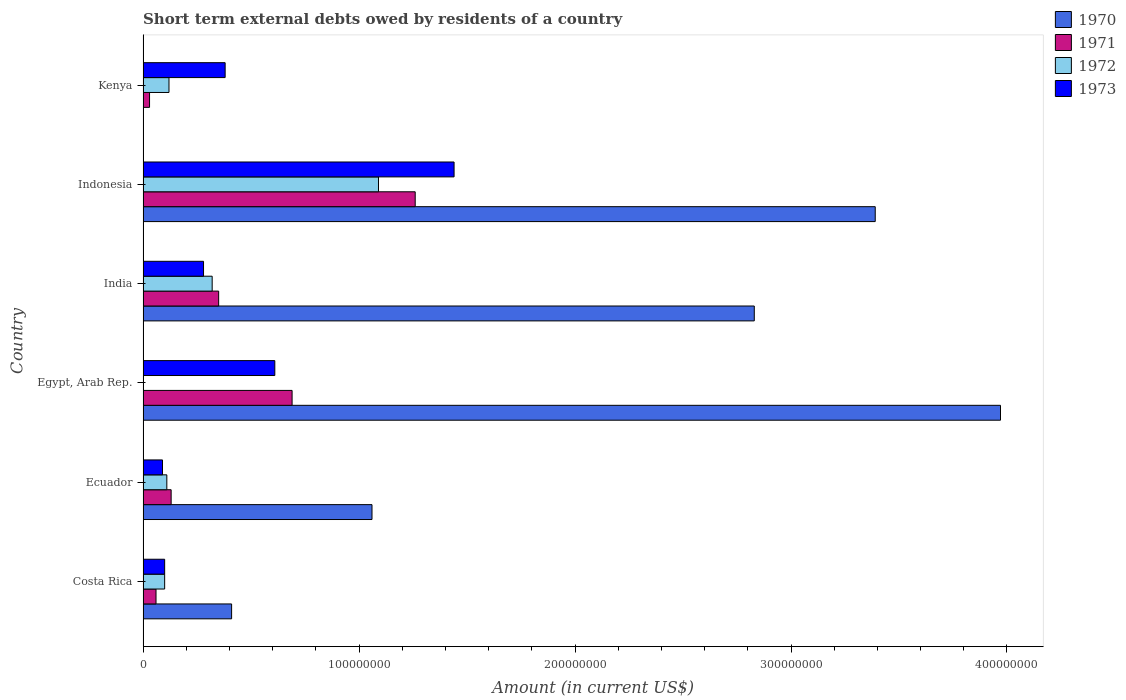How many bars are there on the 2nd tick from the top?
Offer a very short reply. 4. What is the label of the 6th group of bars from the top?
Offer a very short reply. Costa Rica. What is the amount of short-term external debts owed by residents in 1971 in Ecuador?
Give a very brief answer. 1.30e+07. Across all countries, what is the maximum amount of short-term external debts owed by residents in 1972?
Provide a succinct answer. 1.09e+08. Across all countries, what is the minimum amount of short-term external debts owed by residents in 1971?
Provide a short and direct response. 3.00e+06. In which country was the amount of short-term external debts owed by residents in 1972 maximum?
Ensure brevity in your answer.  Indonesia. What is the total amount of short-term external debts owed by residents in 1973 in the graph?
Offer a terse response. 2.90e+08. What is the difference between the amount of short-term external debts owed by residents in 1972 in Costa Rica and that in Ecuador?
Make the answer very short. -1.00e+06. What is the difference between the amount of short-term external debts owed by residents in 1973 in Egypt, Arab Rep. and the amount of short-term external debts owed by residents in 1972 in Costa Rica?
Give a very brief answer. 5.10e+07. What is the average amount of short-term external debts owed by residents in 1973 per country?
Make the answer very short. 4.83e+07. What is the difference between the amount of short-term external debts owed by residents in 1970 and amount of short-term external debts owed by residents in 1972 in Indonesia?
Your answer should be compact. 2.30e+08. What is the ratio of the amount of short-term external debts owed by residents in 1973 in Costa Rica to that in Egypt, Arab Rep.?
Your response must be concise. 0.16. Is the amount of short-term external debts owed by residents in 1973 in Ecuador less than that in Kenya?
Your answer should be very brief. Yes. Is the difference between the amount of short-term external debts owed by residents in 1970 in India and Indonesia greater than the difference between the amount of short-term external debts owed by residents in 1972 in India and Indonesia?
Your answer should be compact. Yes. What is the difference between the highest and the second highest amount of short-term external debts owed by residents in 1970?
Keep it short and to the point. 5.80e+07. What is the difference between the highest and the lowest amount of short-term external debts owed by residents in 1973?
Offer a terse response. 1.35e+08. Is the sum of the amount of short-term external debts owed by residents in 1973 in Costa Rica and India greater than the maximum amount of short-term external debts owed by residents in 1972 across all countries?
Provide a succinct answer. No. Is it the case that in every country, the sum of the amount of short-term external debts owed by residents in 1970 and amount of short-term external debts owed by residents in 1972 is greater than the amount of short-term external debts owed by residents in 1971?
Offer a terse response. Yes. How many countries are there in the graph?
Your answer should be very brief. 6. Does the graph contain any zero values?
Provide a succinct answer. Yes. Does the graph contain grids?
Your answer should be compact. No. What is the title of the graph?
Your answer should be very brief. Short term external debts owed by residents of a country. Does "1995" appear as one of the legend labels in the graph?
Offer a terse response. No. What is the label or title of the X-axis?
Provide a succinct answer. Amount (in current US$). What is the label or title of the Y-axis?
Ensure brevity in your answer.  Country. What is the Amount (in current US$) of 1970 in Costa Rica?
Ensure brevity in your answer.  4.10e+07. What is the Amount (in current US$) in 1972 in Costa Rica?
Ensure brevity in your answer.  1.00e+07. What is the Amount (in current US$) of 1973 in Costa Rica?
Give a very brief answer. 1.00e+07. What is the Amount (in current US$) in 1970 in Ecuador?
Your response must be concise. 1.06e+08. What is the Amount (in current US$) of 1971 in Ecuador?
Give a very brief answer. 1.30e+07. What is the Amount (in current US$) in 1972 in Ecuador?
Keep it short and to the point. 1.10e+07. What is the Amount (in current US$) of 1973 in Ecuador?
Your answer should be very brief. 9.00e+06. What is the Amount (in current US$) in 1970 in Egypt, Arab Rep.?
Offer a very short reply. 3.97e+08. What is the Amount (in current US$) in 1971 in Egypt, Arab Rep.?
Keep it short and to the point. 6.90e+07. What is the Amount (in current US$) in 1972 in Egypt, Arab Rep.?
Provide a short and direct response. 0. What is the Amount (in current US$) in 1973 in Egypt, Arab Rep.?
Keep it short and to the point. 6.10e+07. What is the Amount (in current US$) of 1970 in India?
Ensure brevity in your answer.  2.83e+08. What is the Amount (in current US$) of 1971 in India?
Offer a terse response. 3.50e+07. What is the Amount (in current US$) in 1972 in India?
Make the answer very short. 3.20e+07. What is the Amount (in current US$) of 1973 in India?
Provide a succinct answer. 2.80e+07. What is the Amount (in current US$) in 1970 in Indonesia?
Your answer should be compact. 3.39e+08. What is the Amount (in current US$) of 1971 in Indonesia?
Offer a very short reply. 1.26e+08. What is the Amount (in current US$) of 1972 in Indonesia?
Offer a very short reply. 1.09e+08. What is the Amount (in current US$) in 1973 in Indonesia?
Give a very brief answer. 1.44e+08. What is the Amount (in current US$) in 1970 in Kenya?
Your response must be concise. 0. What is the Amount (in current US$) in 1971 in Kenya?
Ensure brevity in your answer.  3.00e+06. What is the Amount (in current US$) of 1973 in Kenya?
Your answer should be very brief. 3.80e+07. Across all countries, what is the maximum Amount (in current US$) of 1970?
Provide a succinct answer. 3.97e+08. Across all countries, what is the maximum Amount (in current US$) in 1971?
Provide a succinct answer. 1.26e+08. Across all countries, what is the maximum Amount (in current US$) of 1972?
Your response must be concise. 1.09e+08. Across all countries, what is the maximum Amount (in current US$) of 1973?
Your response must be concise. 1.44e+08. Across all countries, what is the minimum Amount (in current US$) of 1971?
Ensure brevity in your answer.  3.00e+06. Across all countries, what is the minimum Amount (in current US$) of 1973?
Offer a terse response. 9.00e+06. What is the total Amount (in current US$) of 1970 in the graph?
Offer a very short reply. 1.17e+09. What is the total Amount (in current US$) in 1971 in the graph?
Ensure brevity in your answer.  2.52e+08. What is the total Amount (in current US$) of 1972 in the graph?
Offer a terse response. 1.74e+08. What is the total Amount (in current US$) in 1973 in the graph?
Your answer should be very brief. 2.90e+08. What is the difference between the Amount (in current US$) of 1970 in Costa Rica and that in Ecuador?
Your answer should be very brief. -6.50e+07. What is the difference between the Amount (in current US$) of 1971 in Costa Rica and that in Ecuador?
Offer a terse response. -7.00e+06. What is the difference between the Amount (in current US$) of 1972 in Costa Rica and that in Ecuador?
Provide a succinct answer. -1.00e+06. What is the difference between the Amount (in current US$) of 1973 in Costa Rica and that in Ecuador?
Offer a terse response. 1.00e+06. What is the difference between the Amount (in current US$) of 1970 in Costa Rica and that in Egypt, Arab Rep.?
Offer a terse response. -3.56e+08. What is the difference between the Amount (in current US$) in 1971 in Costa Rica and that in Egypt, Arab Rep.?
Give a very brief answer. -6.30e+07. What is the difference between the Amount (in current US$) in 1973 in Costa Rica and that in Egypt, Arab Rep.?
Ensure brevity in your answer.  -5.10e+07. What is the difference between the Amount (in current US$) of 1970 in Costa Rica and that in India?
Offer a terse response. -2.42e+08. What is the difference between the Amount (in current US$) of 1971 in Costa Rica and that in India?
Give a very brief answer. -2.90e+07. What is the difference between the Amount (in current US$) of 1972 in Costa Rica and that in India?
Ensure brevity in your answer.  -2.20e+07. What is the difference between the Amount (in current US$) of 1973 in Costa Rica and that in India?
Give a very brief answer. -1.80e+07. What is the difference between the Amount (in current US$) in 1970 in Costa Rica and that in Indonesia?
Provide a short and direct response. -2.98e+08. What is the difference between the Amount (in current US$) in 1971 in Costa Rica and that in Indonesia?
Keep it short and to the point. -1.20e+08. What is the difference between the Amount (in current US$) in 1972 in Costa Rica and that in Indonesia?
Make the answer very short. -9.90e+07. What is the difference between the Amount (in current US$) of 1973 in Costa Rica and that in Indonesia?
Make the answer very short. -1.34e+08. What is the difference between the Amount (in current US$) in 1972 in Costa Rica and that in Kenya?
Ensure brevity in your answer.  -2.00e+06. What is the difference between the Amount (in current US$) of 1973 in Costa Rica and that in Kenya?
Your answer should be very brief. -2.80e+07. What is the difference between the Amount (in current US$) of 1970 in Ecuador and that in Egypt, Arab Rep.?
Give a very brief answer. -2.91e+08. What is the difference between the Amount (in current US$) in 1971 in Ecuador and that in Egypt, Arab Rep.?
Ensure brevity in your answer.  -5.60e+07. What is the difference between the Amount (in current US$) in 1973 in Ecuador and that in Egypt, Arab Rep.?
Offer a very short reply. -5.20e+07. What is the difference between the Amount (in current US$) of 1970 in Ecuador and that in India?
Your response must be concise. -1.77e+08. What is the difference between the Amount (in current US$) in 1971 in Ecuador and that in India?
Provide a short and direct response. -2.20e+07. What is the difference between the Amount (in current US$) in 1972 in Ecuador and that in India?
Give a very brief answer. -2.10e+07. What is the difference between the Amount (in current US$) of 1973 in Ecuador and that in India?
Provide a short and direct response. -1.90e+07. What is the difference between the Amount (in current US$) in 1970 in Ecuador and that in Indonesia?
Provide a succinct answer. -2.33e+08. What is the difference between the Amount (in current US$) in 1971 in Ecuador and that in Indonesia?
Give a very brief answer. -1.13e+08. What is the difference between the Amount (in current US$) of 1972 in Ecuador and that in Indonesia?
Ensure brevity in your answer.  -9.80e+07. What is the difference between the Amount (in current US$) of 1973 in Ecuador and that in Indonesia?
Give a very brief answer. -1.35e+08. What is the difference between the Amount (in current US$) of 1971 in Ecuador and that in Kenya?
Offer a terse response. 1.00e+07. What is the difference between the Amount (in current US$) in 1973 in Ecuador and that in Kenya?
Ensure brevity in your answer.  -2.90e+07. What is the difference between the Amount (in current US$) in 1970 in Egypt, Arab Rep. and that in India?
Keep it short and to the point. 1.14e+08. What is the difference between the Amount (in current US$) in 1971 in Egypt, Arab Rep. and that in India?
Offer a very short reply. 3.40e+07. What is the difference between the Amount (in current US$) of 1973 in Egypt, Arab Rep. and that in India?
Provide a succinct answer. 3.30e+07. What is the difference between the Amount (in current US$) in 1970 in Egypt, Arab Rep. and that in Indonesia?
Your response must be concise. 5.80e+07. What is the difference between the Amount (in current US$) of 1971 in Egypt, Arab Rep. and that in Indonesia?
Your answer should be very brief. -5.70e+07. What is the difference between the Amount (in current US$) of 1973 in Egypt, Arab Rep. and that in Indonesia?
Give a very brief answer. -8.30e+07. What is the difference between the Amount (in current US$) of 1971 in Egypt, Arab Rep. and that in Kenya?
Provide a succinct answer. 6.60e+07. What is the difference between the Amount (in current US$) in 1973 in Egypt, Arab Rep. and that in Kenya?
Provide a succinct answer. 2.30e+07. What is the difference between the Amount (in current US$) in 1970 in India and that in Indonesia?
Keep it short and to the point. -5.60e+07. What is the difference between the Amount (in current US$) in 1971 in India and that in Indonesia?
Give a very brief answer. -9.10e+07. What is the difference between the Amount (in current US$) in 1972 in India and that in Indonesia?
Your answer should be compact. -7.70e+07. What is the difference between the Amount (in current US$) of 1973 in India and that in Indonesia?
Your answer should be compact. -1.16e+08. What is the difference between the Amount (in current US$) of 1971 in India and that in Kenya?
Your answer should be compact. 3.20e+07. What is the difference between the Amount (in current US$) in 1972 in India and that in Kenya?
Provide a short and direct response. 2.00e+07. What is the difference between the Amount (in current US$) of 1973 in India and that in Kenya?
Offer a terse response. -1.00e+07. What is the difference between the Amount (in current US$) of 1971 in Indonesia and that in Kenya?
Your answer should be very brief. 1.23e+08. What is the difference between the Amount (in current US$) of 1972 in Indonesia and that in Kenya?
Provide a succinct answer. 9.70e+07. What is the difference between the Amount (in current US$) in 1973 in Indonesia and that in Kenya?
Provide a succinct answer. 1.06e+08. What is the difference between the Amount (in current US$) in 1970 in Costa Rica and the Amount (in current US$) in 1971 in Ecuador?
Your answer should be very brief. 2.80e+07. What is the difference between the Amount (in current US$) in 1970 in Costa Rica and the Amount (in current US$) in 1972 in Ecuador?
Provide a succinct answer. 3.00e+07. What is the difference between the Amount (in current US$) of 1970 in Costa Rica and the Amount (in current US$) of 1973 in Ecuador?
Make the answer very short. 3.20e+07. What is the difference between the Amount (in current US$) in 1971 in Costa Rica and the Amount (in current US$) in 1972 in Ecuador?
Your answer should be very brief. -5.00e+06. What is the difference between the Amount (in current US$) in 1971 in Costa Rica and the Amount (in current US$) in 1973 in Ecuador?
Make the answer very short. -3.00e+06. What is the difference between the Amount (in current US$) of 1970 in Costa Rica and the Amount (in current US$) of 1971 in Egypt, Arab Rep.?
Offer a terse response. -2.80e+07. What is the difference between the Amount (in current US$) of 1970 in Costa Rica and the Amount (in current US$) of 1973 in Egypt, Arab Rep.?
Keep it short and to the point. -2.00e+07. What is the difference between the Amount (in current US$) of 1971 in Costa Rica and the Amount (in current US$) of 1973 in Egypt, Arab Rep.?
Keep it short and to the point. -5.50e+07. What is the difference between the Amount (in current US$) of 1972 in Costa Rica and the Amount (in current US$) of 1973 in Egypt, Arab Rep.?
Ensure brevity in your answer.  -5.10e+07. What is the difference between the Amount (in current US$) of 1970 in Costa Rica and the Amount (in current US$) of 1972 in India?
Make the answer very short. 9.00e+06. What is the difference between the Amount (in current US$) of 1970 in Costa Rica and the Amount (in current US$) of 1973 in India?
Keep it short and to the point. 1.30e+07. What is the difference between the Amount (in current US$) of 1971 in Costa Rica and the Amount (in current US$) of 1972 in India?
Give a very brief answer. -2.60e+07. What is the difference between the Amount (in current US$) in 1971 in Costa Rica and the Amount (in current US$) in 1973 in India?
Provide a succinct answer. -2.20e+07. What is the difference between the Amount (in current US$) in 1972 in Costa Rica and the Amount (in current US$) in 1973 in India?
Provide a succinct answer. -1.80e+07. What is the difference between the Amount (in current US$) of 1970 in Costa Rica and the Amount (in current US$) of 1971 in Indonesia?
Your response must be concise. -8.50e+07. What is the difference between the Amount (in current US$) of 1970 in Costa Rica and the Amount (in current US$) of 1972 in Indonesia?
Your answer should be very brief. -6.80e+07. What is the difference between the Amount (in current US$) in 1970 in Costa Rica and the Amount (in current US$) in 1973 in Indonesia?
Keep it short and to the point. -1.03e+08. What is the difference between the Amount (in current US$) of 1971 in Costa Rica and the Amount (in current US$) of 1972 in Indonesia?
Give a very brief answer. -1.03e+08. What is the difference between the Amount (in current US$) of 1971 in Costa Rica and the Amount (in current US$) of 1973 in Indonesia?
Give a very brief answer. -1.38e+08. What is the difference between the Amount (in current US$) of 1972 in Costa Rica and the Amount (in current US$) of 1973 in Indonesia?
Your answer should be very brief. -1.34e+08. What is the difference between the Amount (in current US$) in 1970 in Costa Rica and the Amount (in current US$) in 1971 in Kenya?
Give a very brief answer. 3.80e+07. What is the difference between the Amount (in current US$) in 1970 in Costa Rica and the Amount (in current US$) in 1972 in Kenya?
Offer a terse response. 2.90e+07. What is the difference between the Amount (in current US$) of 1971 in Costa Rica and the Amount (in current US$) of 1972 in Kenya?
Your answer should be very brief. -6.00e+06. What is the difference between the Amount (in current US$) in 1971 in Costa Rica and the Amount (in current US$) in 1973 in Kenya?
Provide a succinct answer. -3.20e+07. What is the difference between the Amount (in current US$) of 1972 in Costa Rica and the Amount (in current US$) of 1973 in Kenya?
Your response must be concise. -2.80e+07. What is the difference between the Amount (in current US$) in 1970 in Ecuador and the Amount (in current US$) in 1971 in Egypt, Arab Rep.?
Give a very brief answer. 3.70e+07. What is the difference between the Amount (in current US$) of 1970 in Ecuador and the Amount (in current US$) of 1973 in Egypt, Arab Rep.?
Keep it short and to the point. 4.50e+07. What is the difference between the Amount (in current US$) of 1971 in Ecuador and the Amount (in current US$) of 1973 in Egypt, Arab Rep.?
Give a very brief answer. -4.80e+07. What is the difference between the Amount (in current US$) in 1972 in Ecuador and the Amount (in current US$) in 1973 in Egypt, Arab Rep.?
Offer a terse response. -5.00e+07. What is the difference between the Amount (in current US$) of 1970 in Ecuador and the Amount (in current US$) of 1971 in India?
Your answer should be compact. 7.10e+07. What is the difference between the Amount (in current US$) in 1970 in Ecuador and the Amount (in current US$) in 1972 in India?
Your response must be concise. 7.40e+07. What is the difference between the Amount (in current US$) in 1970 in Ecuador and the Amount (in current US$) in 1973 in India?
Your answer should be very brief. 7.80e+07. What is the difference between the Amount (in current US$) of 1971 in Ecuador and the Amount (in current US$) of 1972 in India?
Your response must be concise. -1.90e+07. What is the difference between the Amount (in current US$) of 1971 in Ecuador and the Amount (in current US$) of 1973 in India?
Give a very brief answer. -1.50e+07. What is the difference between the Amount (in current US$) in 1972 in Ecuador and the Amount (in current US$) in 1973 in India?
Ensure brevity in your answer.  -1.70e+07. What is the difference between the Amount (in current US$) in 1970 in Ecuador and the Amount (in current US$) in 1971 in Indonesia?
Your answer should be very brief. -2.00e+07. What is the difference between the Amount (in current US$) in 1970 in Ecuador and the Amount (in current US$) in 1973 in Indonesia?
Make the answer very short. -3.80e+07. What is the difference between the Amount (in current US$) of 1971 in Ecuador and the Amount (in current US$) of 1972 in Indonesia?
Your answer should be very brief. -9.60e+07. What is the difference between the Amount (in current US$) in 1971 in Ecuador and the Amount (in current US$) in 1973 in Indonesia?
Your answer should be compact. -1.31e+08. What is the difference between the Amount (in current US$) of 1972 in Ecuador and the Amount (in current US$) of 1973 in Indonesia?
Your response must be concise. -1.33e+08. What is the difference between the Amount (in current US$) in 1970 in Ecuador and the Amount (in current US$) in 1971 in Kenya?
Ensure brevity in your answer.  1.03e+08. What is the difference between the Amount (in current US$) of 1970 in Ecuador and the Amount (in current US$) of 1972 in Kenya?
Your answer should be compact. 9.40e+07. What is the difference between the Amount (in current US$) of 1970 in Ecuador and the Amount (in current US$) of 1973 in Kenya?
Ensure brevity in your answer.  6.80e+07. What is the difference between the Amount (in current US$) of 1971 in Ecuador and the Amount (in current US$) of 1973 in Kenya?
Provide a succinct answer. -2.50e+07. What is the difference between the Amount (in current US$) of 1972 in Ecuador and the Amount (in current US$) of 1973 in Kenya?
Provide a short and direct response. -2.70e+07. What is the difference between the Amount (in current US$) in 1970 in Egypt, Arab Rep. and the Amount (in current US$) in 1971 in India?
Provide a succinct answer. 3.62e+08. What is the difference between the Amount (in current US$) of 1970 in Egypt, Arab Rep. and the Amount (in current US$) of 1972 in India?
Your answer should be compact. 3.65e+08. What is the difference between the Amount (in current US$) in 1970 in Egypt, Arab Rep. and the Amount (in current US$) in 1973 in India?
Your answer should be very brief. 3.69e+08. What is the difference between the Amount (in current US$) in 1971 in Egypt, Arab Rep. and the Amount (in current US$) in 1972 in India?
Make the answer very short. 3.70e+07. What is the difference between the Amount (in current US$) in 1971 in Egypt, Arab Rep. and the Amount (in current US$) in 1973 in India?
Offer a very short reply. 4.10e+07. What is the difference between the Amount (in current US$) in 1970 in Egypt, Arab Rep. and the Amount (in current US$) in 1971 in Indonesia?
Keep it short and to the point. 2.71e+08. What is the difference between the Amount (in current US$) in 1970 in Egypt, Arab Rep. and the Amount (in current US$) in 1972 in Indonesia?
Ensure brevity in your answer.  2.88e+08. What is the difference between the Amount (in current US$) in 1970 in Egypt, Arab Rep. and the Amount (in current US$) in 1973 in Indonesia?
Give a very brief answer. 2.53e+08. What is the difference between the Amount (in current US$) of 1971 in Egypt, Arab Rep. and the Amount (in current US$) of 1972 in Indonesia?
Keep it short and to the point. -4.00e+07. What is the difference between the Amount (in current US$) of 1971 in Egypt, Arab Rep. and the Amount (in current US$) of 1973 in Indonesia?
Offer a very short reply. -7.50e+07. What is the difference between the Amount (in current US$) in 1970 in Egypt, Arab Rep. and the Amount (in current US$) in 1971 in Kenya?
Keep it short and to the point. 3.94e+08. What is the difference between the Amount (in current US$) in 1970 in Egypt, Arab Rep. and the Amount (in current US$) in 1972 in Kenya?
Your response must be concise. 3.85e+08. What is the difference between the Amount (in current US$) of 1970 in Egypt, Arab Rep. and the Amount (in current US$) of 1973 in Kenya?
Give a very brief answer. 3.59e+08. What is the difference between the Amount (in current US$) of 1971 in Egypt, Arab Rep. and the Amount (in current US$) of 1972 in Kenya?
Offer a very short reply. 5.70e+07. What is the difference between the Amount (in current US$) in 1971 in Egypt, Arab Rep. and the Amount (in current US$) in 1973 in Kenya?
Make the answer very short. 3.10e+07. What is the difference between the Amount (in current US$) in 1970 in India and the Amount (in current US$) in 1971 in Indonesia?
Offer a very short reply. 1.57e+08. What is the difference between the Amount (in current US$) in 1970 in India and the Amount (in current US$) in 1972 in Indonesia?
Your response must be concise. 1.74e+08. What is the difference between the Amount (in current US$) in 1970 in India and the Amount (in current US$) in 1973 in Indonesia?
Offer a very short reply. 1.39e+08. What is the difference between the Amount (in current US$) of 1971 in India and the Amount (in current US$) of 1972 in Indonesia?
Your answer should be compact. -7.40e+07. What is the difference between the Amount (in current US$) of 1971 in India and the Amount (in current US$) of 1973 in Indonesia?
Give a very brief answer. -1.09e+08. What is the difference between the Amount (in current US$) of 1972 in India and the Amount (in current US$) of 1973 in Indonesia?
Offer a very short reply. -1.12e+08. What is the difference between the Amount (in current US$) of 1970 in India and the Amount (in current US$) of 1971 in Kenya?
Give a very brief answer. 2.80e+08. What is the difference between the Amount (in current US$) of 1970 in India and the Amount (in current US$) of 1972 in Kenya?
Offer a very short reply. 2.71e+08. What is the difference between the Amount (in current US$) of 1970 in India and the Amount (in current US$) of 1973 in Kenya?
Offer a terse response. 2.45e+08. What is the difference between the Amount (in current US$) of 1971 in India and the Amount (in current US$) of 1972 in Kenya?
Provide a short and direct response. 2.30e+07. What is the difference between the Amount (in current US$) in 1972 in India and the Amount (in current US$) in 1973 in Kenya?
Your answer should be very brief. -6.00e+06. What is the difference between the Amount (in current US$) in 1970 in Indonesia and the Amount (in current US$) in 1971 in Kenya?
Make the answer very short. 3.36e+08. What is the difference between the Amount (in current US$) of 1970 in Indonesia and the Amount (in current US$) of 1972 in Kenya?
Give a very brief answer. 3.27e+08. What is the difference between the Amount (in current US$) in 1970 in Indonesia and the Amount (in current US$) in 1973 in Kenya?
Give a very brief answer. 3.01e+08. What is the difference between the Amount (in current US$) in 1971 in Indonesia and the Amount (in current US$) in 1972 in Kenya?
Make the answer very short. 1.14e+08. What is the difference between the Amount (in current US$) of 1971 in Indonesia and the Amount (in current US$) of 1973 in Kenya?
Provide a succinct answer. 8.80e+07. What is the difference between the Amount (in current US$) of 1972 in Indonesia and the Amount (in current US$) of 1973 in Kenya?
Your answer should be very brief. 7.10e+07. What is the average Amount (in current US$) in 1970 per country?
Offer a terse response. 1.94e+08. What is the average Amount (in current US$) of 1971 per country?
Give a very brief answer. 4.20e+07. What is the average Amount (in current US$) of 1972 per country?
Offer a terse response. 2.90e+07. What is the average Amount (in current US$) in 1973 per country?
Your answer should be very brief. 4.83e+07. What is the difference between the Amount (in current US$) in 1970 and Amount (in current US$) in 1971 in Costa Rica?
Provide a succinct answer. 3.50e+07. What is the difference between the Amount (in current US$) in 1970 and Amount (in current US$) in 1972 in Costa Rica?
Provide a short and direct response. 3.10e+07. What is the difference between the Amount (in current US$) of 1970 and Amount (in current US$) of 1973 in Costa Rica?
Make the answer very short. 3.10e+07. What is the difference between the Amount (in current US$) of 1971 and Amount (in current US$) of 1972 in Costa Rica?
Provide a succinct answer. -4.00e+06. What is the difference between the Amount (in current US$) of 1971 and Amount (in current US$) of 1973 in Costa Rica?
Your answer should be compact. -4.00e+06. What is the difference between the Amount (in current US$) in 1972 and Amount (in current US$) in 1973 in Costa Rica?
Keep it short and to the point. 0. What is the difference between the Amount (in current US$) in 1970 and Amount (in current US$) in 1971 in Ecuador?
Ensure brevity in your answer.  9.30e+07. What is the difference between the Amount (in current US$) of 1970 and Amount (in current US$) of 1972 in Ecuador?
Your answer should be compact. 9.50e+07. What is the difference between the Amount (in current US$) in 1970 and Amount (in current US$) in 1973 in Ecuador?
Your response must be concise. 9.70e+07. What is the difference between the Amount (in current US$) of 1971 and Amount (in current US$) of 1972 in Ecuador?
Provide a succinct answer. 2.00e+06. What is the difference between the Amount (in current US$) of 1971 and Amount (in current US$) of 1973 in Ecuador?
Your response must be concise. 4.00e+06. What is the difference between the Amount (in current US$) in 1970 and Amount (in current US$) in 1971 in Egypt, Arab Rep.?
Your answer should be very brief. 3.28e+08. What is the difference between the Amount (in current US$) in 1970 and Amount (in current US$) in 1973 in Egypt, Arab Rep.?
Your response must be concise. 3.36e+08. What is the difference between the Amount (in current US$) of 1971 and Amount (in current US$) of 1973 in Egypt, Arab Rep.?
Keep it short and to the point. 8.00e+06. What is the difference between the Amount (in current US$) of 1970 and Amount (in current US$) of 1971 in India?
Keep it short and to the point. 2.48e+08. What is the difference between the Amount (in current US$) in 1970 and Amount (in current US$) in 1972 in India?
Your response must be concise. 2.51e+08. What is the difference between the Amount (in current US$) of 1970 and Amount (in current US$) of 1973 in India?
Your response must be concise. 2.55e+08. What is the difference between the Amount (in current US$) of 1971 and Amount (in current US$) of 1973 in India?
Your answer should be very brief. 7.00e+06. What is the difference between the Amount (in current US$) of 1970 and Amount (in current US$) of 1971 in Indonesia?
Offer a very short reply. 2.13e+08. What is the difference between the Amount (in current US$) in 1970 and Amount (in current US$) in 1972 in Indonesia?
Provide a short and direct response. 2.30e+08. What is the difference between the Amount (in current US$) in 1970 and Amount (in current US$) in 1973 in Indonesia?
Your answer should be very brief. 1.95e+08. What is the difference between the Amount (in current US$) of 1971 and Amount (in current US$) of 1972 in Indonesia?
Make the answer very short. 1.70e+07. What is the difference between the Amount (in current US$) of 1971 and Amount (in current US$) of 1973 in Indonesia?
Offer a terse response. -1.80e+07. What is the difference between the Amount (in current US$) of 1972 and Amount (in current US$) of 1973 in Indonesia?
Ensure brevity in your answer.  -3.50e+07. What is the difference between the Amount (in current US$) of 1971 and Amount (in current US$) of 1972 in Kenya?
Your response must be concise. -9.00e+06. What is the difference between the Amount (in current US$) of 1971 and Amount (in current US$) of 1973 in Kenya?
Offer a very short reply. -3.50e+07. What is the difference between the Amount (in current US$) of 1972 and Amount (in current US$) of 1973 in Kenya?
Give a very brief answer. -2.60e+07. What is the ratio of the Amount (in current US$) of 1970 in Costa Rica to that in Ecuador?
Provide a succinct answer. 0.39. What is the ratio of the Amount (in current US$) in 1971 in Costa Rica to that in Ecuador?
Your response must be concise. 0.46. What is the ratio of the Amount (in current US$) in 1973 in Costa Rica to that in Ecuador?
Offer a very short reply. 1.11. What is the ratio of the Amount (in current US$) of 1970 in Costa Rica to that in Egypt, Arab Rep.?
Keep it short and to the point. 0.1. What is the ratio of the Amount (in current US$) in 1971 in Costa Rica to that in Egypt, Arab Rep.?
Provide a short and direct response. 0.09. What is the ratio of the Amount (in current US$) of 1973 in Costa Rica to that in Egypt, Arab Rep.?
Offer a very short reply. 0.16. What is the ratio of the Amount (in current US$) of 1970 in Costa Rica to that in India?
Your answer should be compact. 0.14. What is the ratio of the Amount (in current US$) of 1971 in Costa Rica to that in India?
Offer a very short reply. 0.17. What is the ratio of the Amount (in current US$) of 1972 in Costa Rica to that in India?
Your answer should be very brief. 0.31. What is the ratio of the Amount (in current US$) in 1973 in Costa Rica to that in India?
Your answer should be very brief. 0.36. What is the ratio of the Amount (in current US$) of 1970 in Costa Rica to that in Indonesia?
Keep it short and to the point. 0.12. What is the ratio of the Amount (in current US$) in 1971 in Costa Rica to that in Indonesia?
Give a very brief answer. 0.05. What is the ratio of the Amount (in current US$) of 1972 in Costa Rica to that in Indonesia?
Your answer should be very brief. 0.09. What is the ratio of the Amount (in current US$) of 1973 in Costa Rica to that in Indonesia?
Your answer should be very brief. 0.07. What is the ratio of the Amount (in current US$) of 1971 in Costa Rica to that in Kenya?
Your response must be concise. 2. What is the ratio of the Amount (in current US$) of 1972 in Costa Rica to that in Kenya?
Provide a succinct answer. 0.83. What is the ratio of the Amount (in current US$) in 1973 in Costa Rica to that in Kenya?
Offer a terse response. 0.26. What is the ratio of the Amount (in current US$) of 1970 in Ecuador to that in Egypt, Arab Rep.?
Keep it short and to the point. 0.27. What is the ratio of the Amount (in current US$) of 1971 in Ecuador to that in Egypt, Arab Rep.?
Offer a very short reply. 0.19. What is the ratio of the Amount (in current US$) in 1973 in Ecuador to that in Egypt, Arab Rep.?
Provide a succinct answer. 0.15. What is the ratio of the Amount (in current US$) in 1970 in Ecuador to that in India?
Keep it short and to the point. 0.37. What is the ratio of the Amount (in current US$) in 1971 in Ecuador to that in India?
Your answer should be very brief. 0.37. What is the ratio of the Amount (in current US$) in 1972 in Ecuador to that in India?
Keep it short and to the point. 0.34. What is the ratio of the Amount (in current US$) in 1973 in Ecuador to that in India?
Offer a very short reply. 0.32. What is the ratio of the Amount (in current US$) in 1970 in Ecuador to that in Indonesia?
Ensure brevity in your answer.  0.31. What is the ratio of the Amount (in current US$) in 1971 in Ecuador to that in Indonesia?
Provide a short and direct response. 0.1. What is the ratio of the Amount (in current US$) in 1972 in Ecuador to that in Indonesia?
Your answer should be very brief. 0.1. What is the ratio of the Amount (in current US$) of 1973 in Ecuador to that in Indonesia?
Keep it short and to the point. 0.06. What is the ratio of the Amount (in current US$) of 1971 in Ecuador to that in Kenya?
Your answer should be compact. 4.33. What is the ratio of the Amount (in current US$) in 1972 in Ecuador to that in Kenya?
Your answer should be very brief. 0.92. What is the ratio of the Amount (in current US$) in 1973 in Ecuador to that in Kenya?
Provide a short and direct response. 0.24. What is the ratio of the Amount (in current US$) in 1970 in Egypt, Arab Rep. to that in India?
Give a very brief answer. 1.4. What is the ratio of the Amount (in current US$) in 1971 in Egypt, Arab Rep. to that in India?
Offer a very short reply. 1.97. What is the ratio of the Amount (in current US$) of 1973 in Egypt, Arab Rep. to that in India?
Ensure brevity in your answer.  2.18. What is the ratio of the Amount (in current US$) of 1970 in Egypt, Arab Rep. to that in Indonesia?
Your answer should be compact. 1.17. What is the ratio of the Amount (in current US$) of 1971 in Egypt, Arab Rep. to that in Indonesia?
Your answer should be very brief. 0.55. What is the ratio of the Amount (in current US$) of 1973 in Egypt, Arab Rep. to that in Indonesia?
Provide a short and direct response. 0.42. What is the ratio of the Amount (in current US$) of 1971 in Egypt, Arab Rep. to that in Kenya?
Provide a succinct answer. 23. What is the ratio of the Amount (in current US$) of 1973 in Egypt, Arab Rep. to that in Kenya?
Ensure brevity in your answer.  1.61. What is the ratio of the Amount (in current US$) of 1970 in India to that in Indonesia?
Provide a succinct answer. 0.83. What is the ratio of the Amount (in current US$) of 1971 in India to that in Indonesia?
Make the answer very short. 0.28. What is the ratio of the Amount (in current US$) in 1972 in India to that in Indonesia?
Give a very brief answer. 0.29. What is the ratio of the Amount (in current US$) of 1973 in India to that in Indonesia?
Offer a very short reply. 0.19. What is the ratio of the Amount (in current US$) of 1971 in India to that in Kenya?
Provide a short and direct response. 11.67. What is the ratio of the Amount (in current US$) of 1972 in India to that in Kenya?
Offer a terse response. 2.67. What is the ratio of the Amount (in current US$) in 1973 in India to that in Kenya?
Offer a terse response. 0.74. What is the ratio of the Amount (in current US$) of 1971 in Indonesia to that in Kenya?
Provide a succinct answer. 42. What is the ratio of the Amount (in current US$) in 1972 in Indonesia to that in Kenya?
Your answer should be very brief. 9.08. What is the ratio of the Amount (in current US$) in 1973 in Indonesia to that in Kenya?
Keep it short and to the point. 3.79. What is the difference between the highest and the second highest Amount (in current US$) in 1970?
Offer a very short reply. 5.80e+07. What is the difference between the highest and the second highest Amount (in current US$) in 1971?
Provide a short and direct response. 5.70e+07. What is the difference between the highest and the second highest Amount (in current US$) of 1972?
Your answer should be compact. 7.70e+07. What is the difference between the highest and the second highest Amount (in current US$) of 1973?
Offer a very short reply. 8.30e+07. What is the difference between the highest and the lowest Amount (in current US$) in 1970?
Provide a succinct answer. 3.97e+08. What is the difference between the highest and the lowest Amount (in current US$) in 1971?
Your response must be concise. 1.23e+08. What is the difference between the highest and the lowest Amount (in current US$) in 1972?
Your answer should be very brief. 1.09e+08. What is the difference between the highest and the lowest Amount (in current US$) of 1973?
Give a very brief answer. 1.35e+08. 